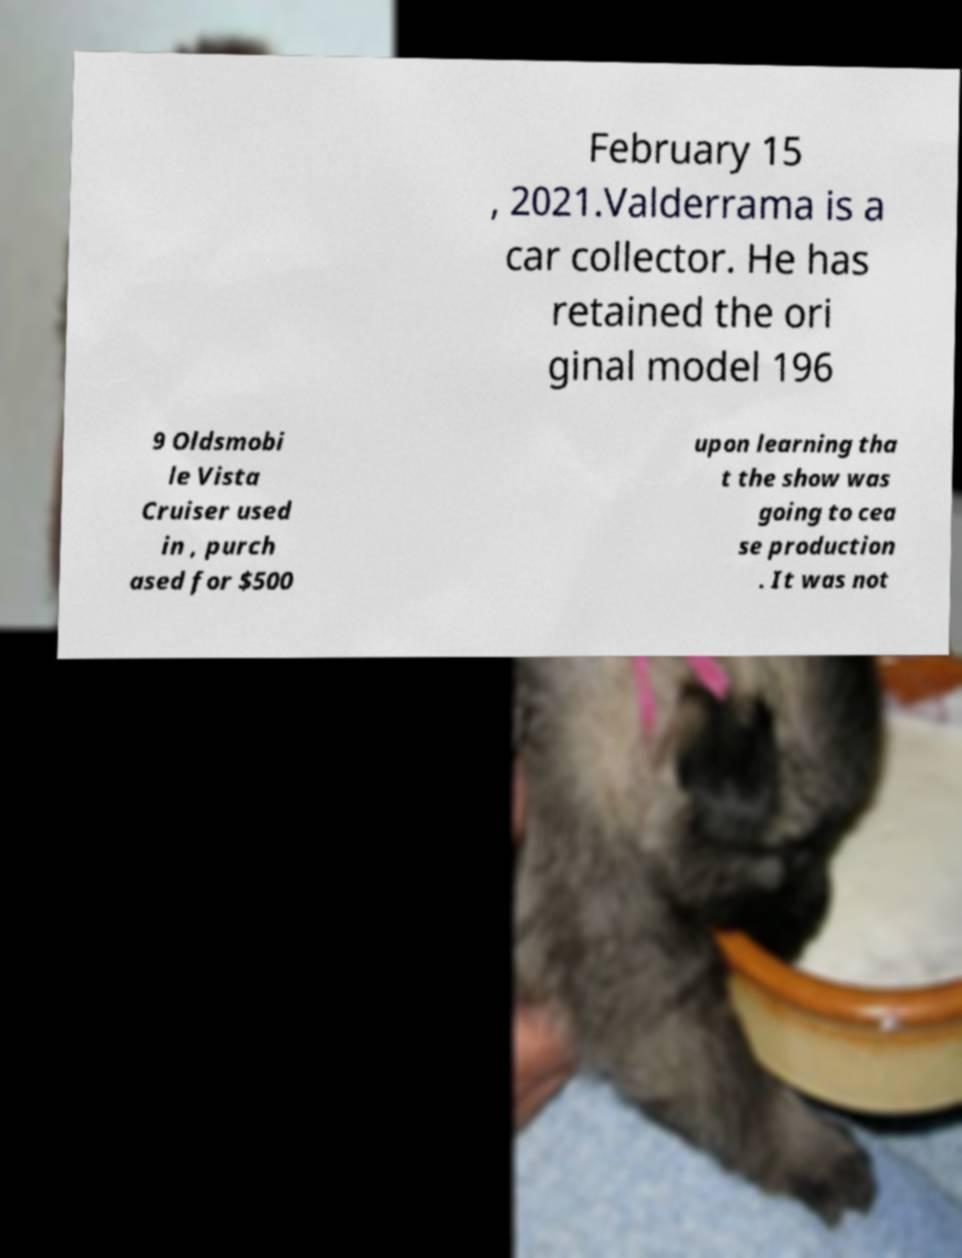Can you accurately transcribe the text from the provided image for me? February 15 , 2021.Valderrama is a car collector. He has retained the ori ginal model 196 9 Oldsmobi le Vista Cruiser used in , purch ased for $500 upon learning tha t the show was going to cea se production . It was not 